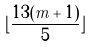<formula> <loc_0><loc_0><loc_500><loc_500>\lfloor \frac { 1 3 ( m + 1 ) } { 5 } \rfloor</formula> 